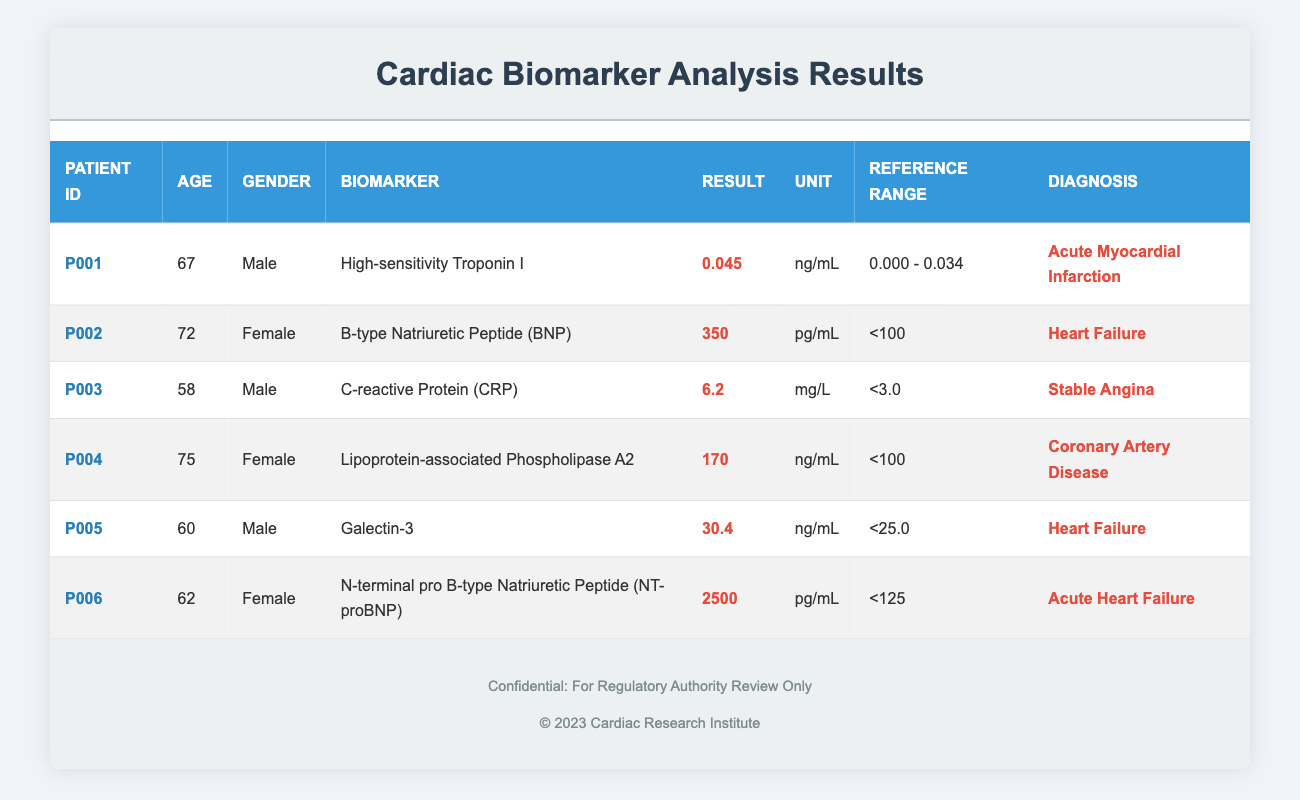What is the highest result recorded for a biomarker? By examining the results column, the highest value is 2500 pg/mL, recorded for the biomarker N-terminal pro B-type Natriuretic Peptide in patient P006.
Answer: 2500 pg/mL How many female patients are in the study? The table lists three female patients: P002, P004, and P006. Therefore, there are three female patients.
Answer: 3 What is the reference range for Galectin-3? The reference range for Galectin-3, as indicated in the table, is <25.0 ng/mL.
Answer: <25.0 ng/mL Is the result for High-sensitivity Troponin I within the reference range? The result for High-sensitivity Troponin I is 0.045 ng/mL, which exceeds the reference range of 0.000 - 0.034 ng/mL, hence it is out of range.
Answer: No What is the average age of the patients exhibiting out-of-range biomarker results? The patients with out-of-range results are P001 (67), P002 (72), P003 (58), P004 (75), P005 (60), and P006 (62). The sum of their ages is 67 + 72 + 58 + 75 + 60 + 62 = 394. There are six patients, so the average age is 394 / 6 = 65.67.
Answer: 65.67 Which biomarker has the highest recorded result, and what is its diagnosis? From the table, N-terminal pro B-type Natriuretic Peptide has the highest recorded result of 2500 pg/mL and is associated with the diagnosis of Acute Heart Failure.
Answer: N-terminal pro B-type Natriuretic Peptide; Acute Heart Failure How many patients have a diagnosis of heart failure? The diagnoses related to heart failure are listed for two patients: P002 (Heart Failure) and P005 (Heart Failure). Thus, there are two patients with this diagnosis.
Answer: 2 What is the range of results for Lipoprotein-associated Phospholipase A2? The result for Lipoprotein-associated Phospholipase A2 is 170 ng/mL, and its reference range is <100 ng/mL, indicating that it is above the reference range.
Answer: <100 ng/mL Is there any patient diagnosed with Stable Angina who has a biomarker result greater than 5 mg/L? The patient diagnosed with Stable Angina is P003 and has a biomarker result of 6.2 mg/L, which is greater than 5 mg/L.
Answer: Yes 